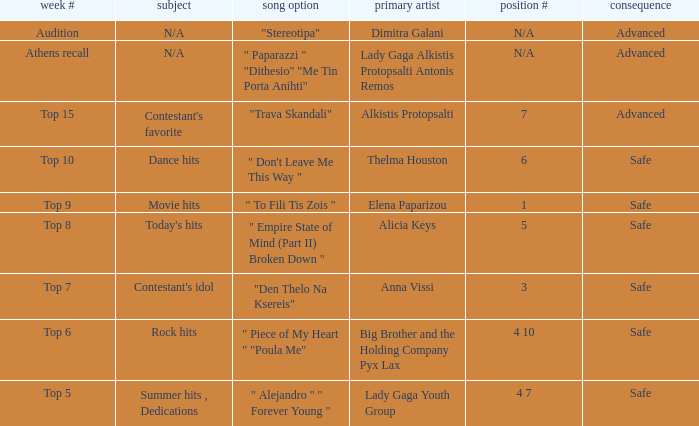Which song was chosen during the audition week? "Stereotipa". 